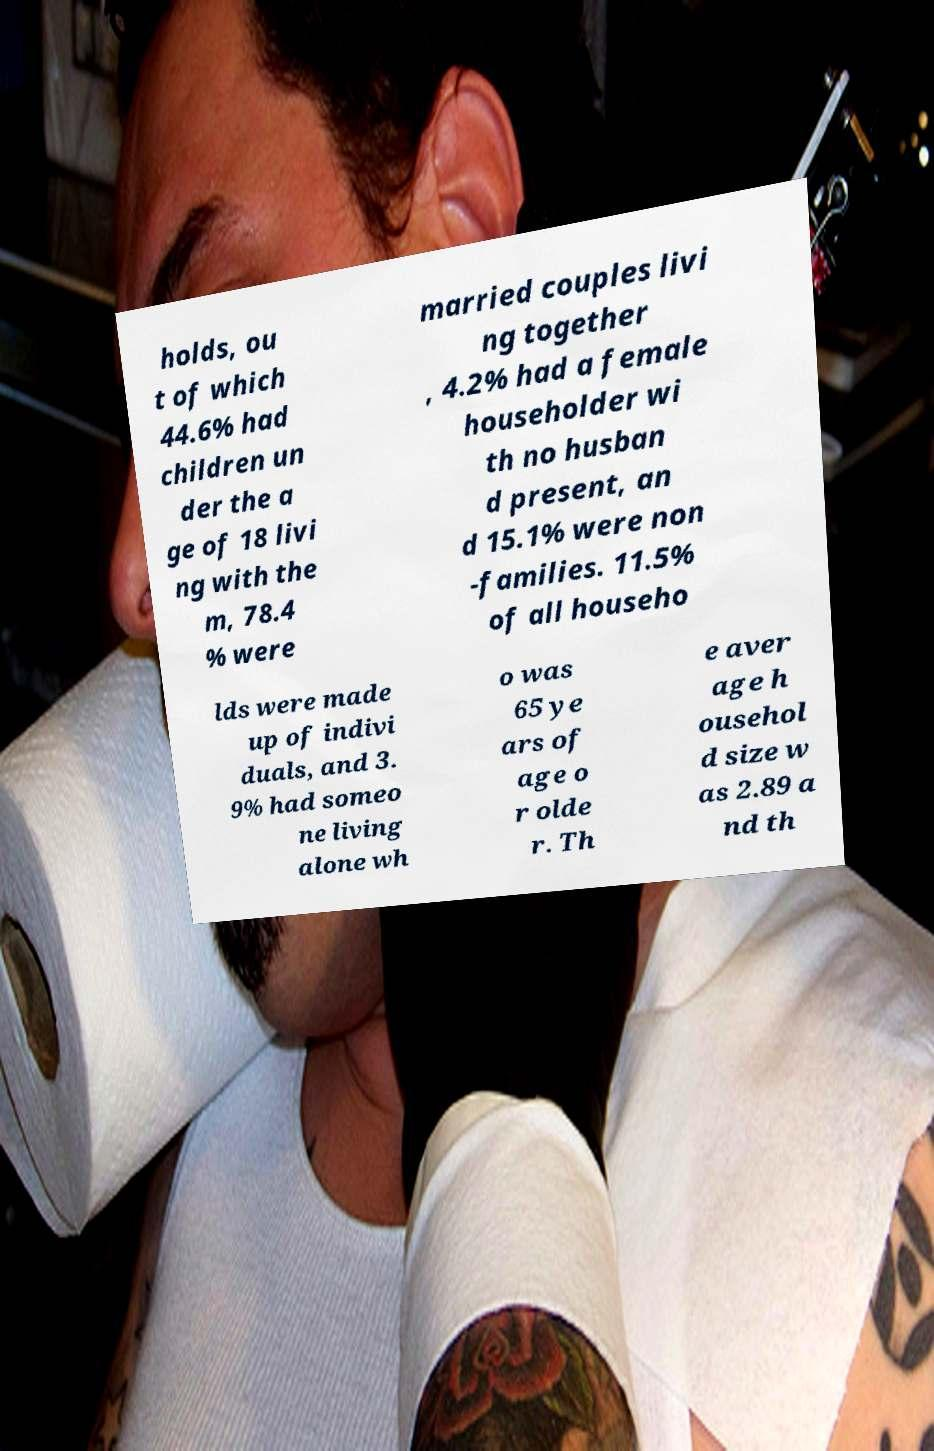Can you accurately transcribe the text from the provided image for me? holds, ou t of which 44.6% had children un der the a ge of 18 livi ng with the m, 78.4 % were married couples livi ng together , 4.2% had a female householder wi th no husban d present, an d 15.1% were non -families. 11.5% of all househo lds were made up of indivi duals, and 3. 9% had someo ne living alone wh o was 65 ye ars of age o r olde r. Th e aver age h ousehol d size w as 2.89 a nd th 